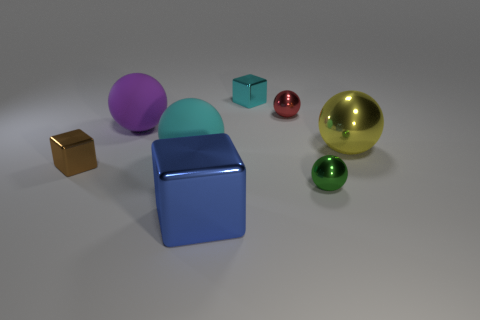How many tiny shiny things are on the right side of the blue metallic object and in front of the cyan block?
Make the answer very short. 2. What is the tiny object that is in front of the red thing and on the left side of the red ball made of?
Ensure brevity in your answer.  Metal. Are there fewer small cubes that are in front of the red metal ball than big cyan rubber spheres on the right side of the blue block?
Give a very brief answer. No. What is the size of the cyan block that is made of the same material as the large yellow object?
Offer a very short reply. Small. Is there any other thing that has the same color as the large shiny cube?
Your response must be concise. No. Are the large yellow thing and the cyan object that is in front of the tiny cyan cube made of the same material?
Your answer should be compact. No. There is a large thing that is the same shape as the tiny cyan shiny thing; what is its material?
Provide a succinct answer. Metal. Do the big ball right of the small red ball and the tiny object that is on the left side of the big cube have the same material?
Provide a succinct answer. Yes. What color is the big metallic thing that is in front of the cyan thing in front of the big shiny thing on the right side of the large blue object?
Your answer should be compact. Blue. What number of other things are there of the same shape as the cyan metallic object?
Keep it short and to the point. 2. 